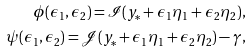Convert formula to latex. <formula><loc_0><loc_0><loc_500><loc_500>\phi ( \epsilon _ { 1 } , \epsilon _ { 2 } ) = \mathcal { I } ( y _ { \ast } + \epsilon _ { 1 } \eta _ { 1 } + \epsilon _ { 2 } \eta _ { 2 } ) , \\ \psi ( \epsilon _ { 1 } , \epsilon _ { 2 } ) = \mathcal { J } ( y _ { \ast } + \epsilon _ { 1 } \eta _ { 1 } + \epsilon _ { 2 } \eta _ { 2 } ) - \gamma ,</formula> 